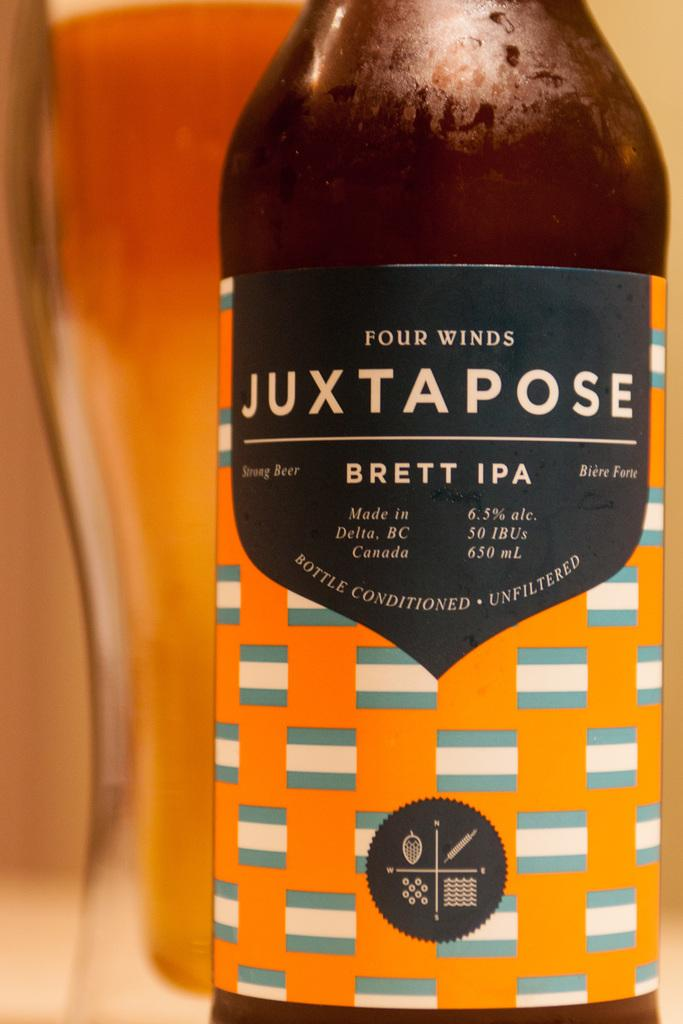<image>
Present a compact description of the photo's key features. Bottle for Four Winds Juxtapose with a label showing blue and white flags. 